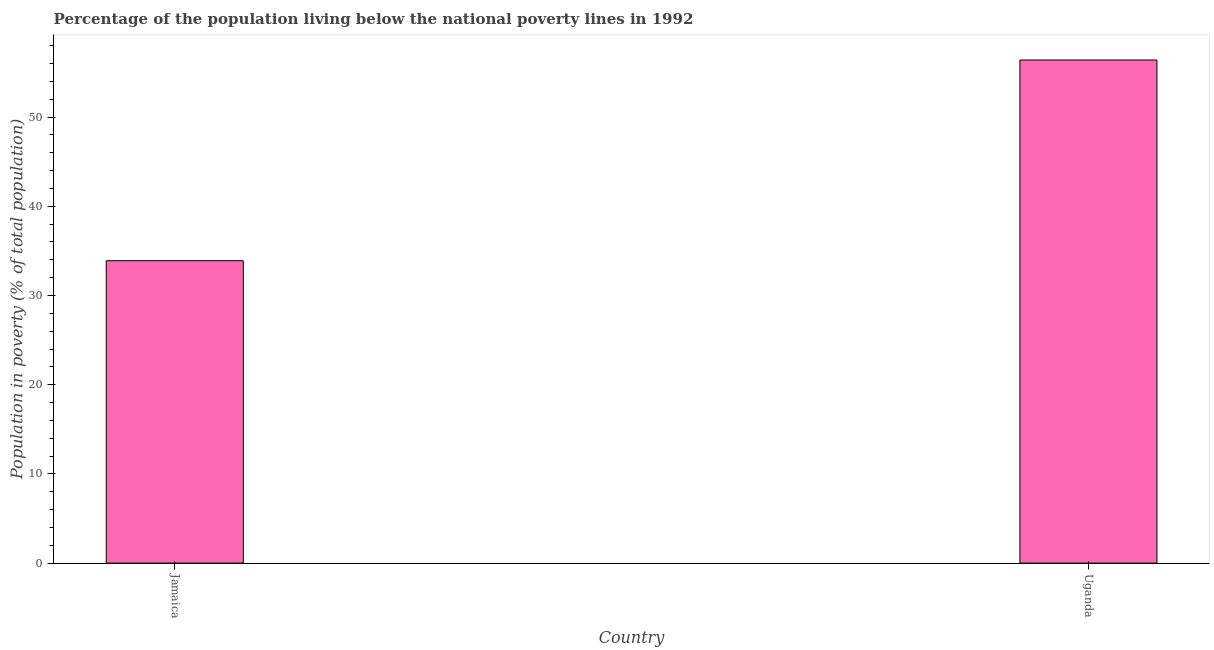Does the graph contain grids?
Offer a terse response. No. What is the title of the graph?
Provide a succinct answer. Percentage of the population living below the national poverty lines in 1992. What is the label or title of the X-axis?
Offer a terse response. Country. What is the label or title of the Y-axis?
Your response must be concise. Population in poverty (% of total population). What is the percentage of population living below poverty line in Uganda?
Your answer should be very brief. 56.4. Across all countries, what is the maximum percentage of population living below poverty line?
Keep it short and to the point. 56.4. Across all countries, what is the minimum percentage of population living below poverty line?
Ensure brevity in your answer.  33.9. In which country was the percentage of population living below poverty line maximum?
Provide a succinct answer. Uganda. In which country was the percentage of population living below poverty line minimum?
Make the answer very short. Jamaica. What is the sum of the percentage of population living below poverty line?
Offer a terse response. 90.3. What is the difference between the percentage of population living below poverty line in Jamaica and Uganda?
Make the answer very short. -22.5. What is the average percentage of population living below poverty line per country?
Ensure brevity in your answer.  45.15. What is the median percentage of population living below poverty line?
Offer a terse response. 45.15. What is the ratio of the percentage of population living below poverty line in Jamaica to that in Uganda?
Keep it short and to the point. 0.6. Is the percentage of population living below poverty line in Jamaica less than that in Uganda?
Provide a succinct answer. Yes. In how many countries, is the percentage of population living below poverty line greater than the average percentage of population living below poverty line taken over all countries?
Make the answer very short. 1. How many bars are there?
Your response must be concise. 2. Are all the bars in the graph horizontal?
Ensure brevity in your answer.  No. Are the values on the major ticks of Y-axis written in scientific E-notation?
Ensure brevity in your answer.  No. What is the Population in poverty (% of total population) in Jamaica?
Your response must be concise. 33.9. What is the Population in poverty (% of total population) of Uganda?
Your answer should be compact. 56.4. What is the difference between the Population in poverty (% of total population) in Jamaica and Uganda?
Keep it short and to the point. -22.5. What is the ratio of the Population in poverty (% of total population) in Jamaica to that in Uganda?
Your response must be concise. 0.6. 